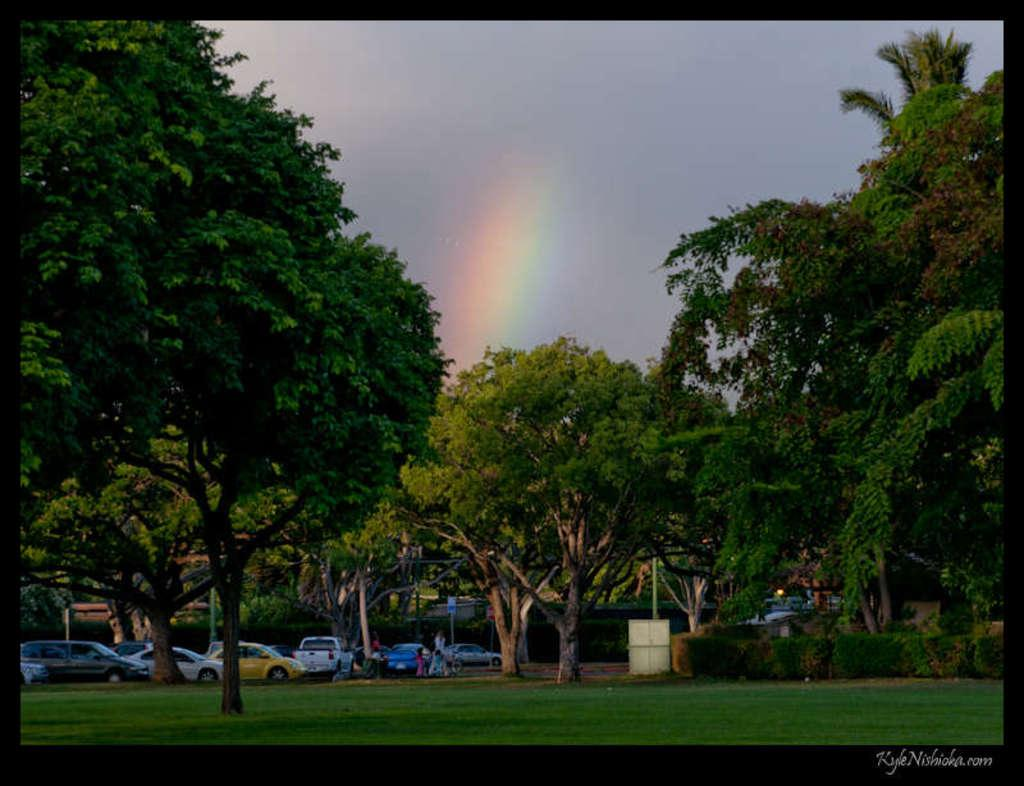What type of vegetation can be seen in the image? There are trees and grass in the image. What else is present in the image besides vegetation? There are vehicles and people in the image. What can be seen in the background of the image? The sky is visible in the background of the image, and there is a rainbow. What color is the crayon used to draw the zinc in the image? There is no crayon or zinc present in the image; it features trees, grass, vehicles, people, the sky, and a rainbow. 